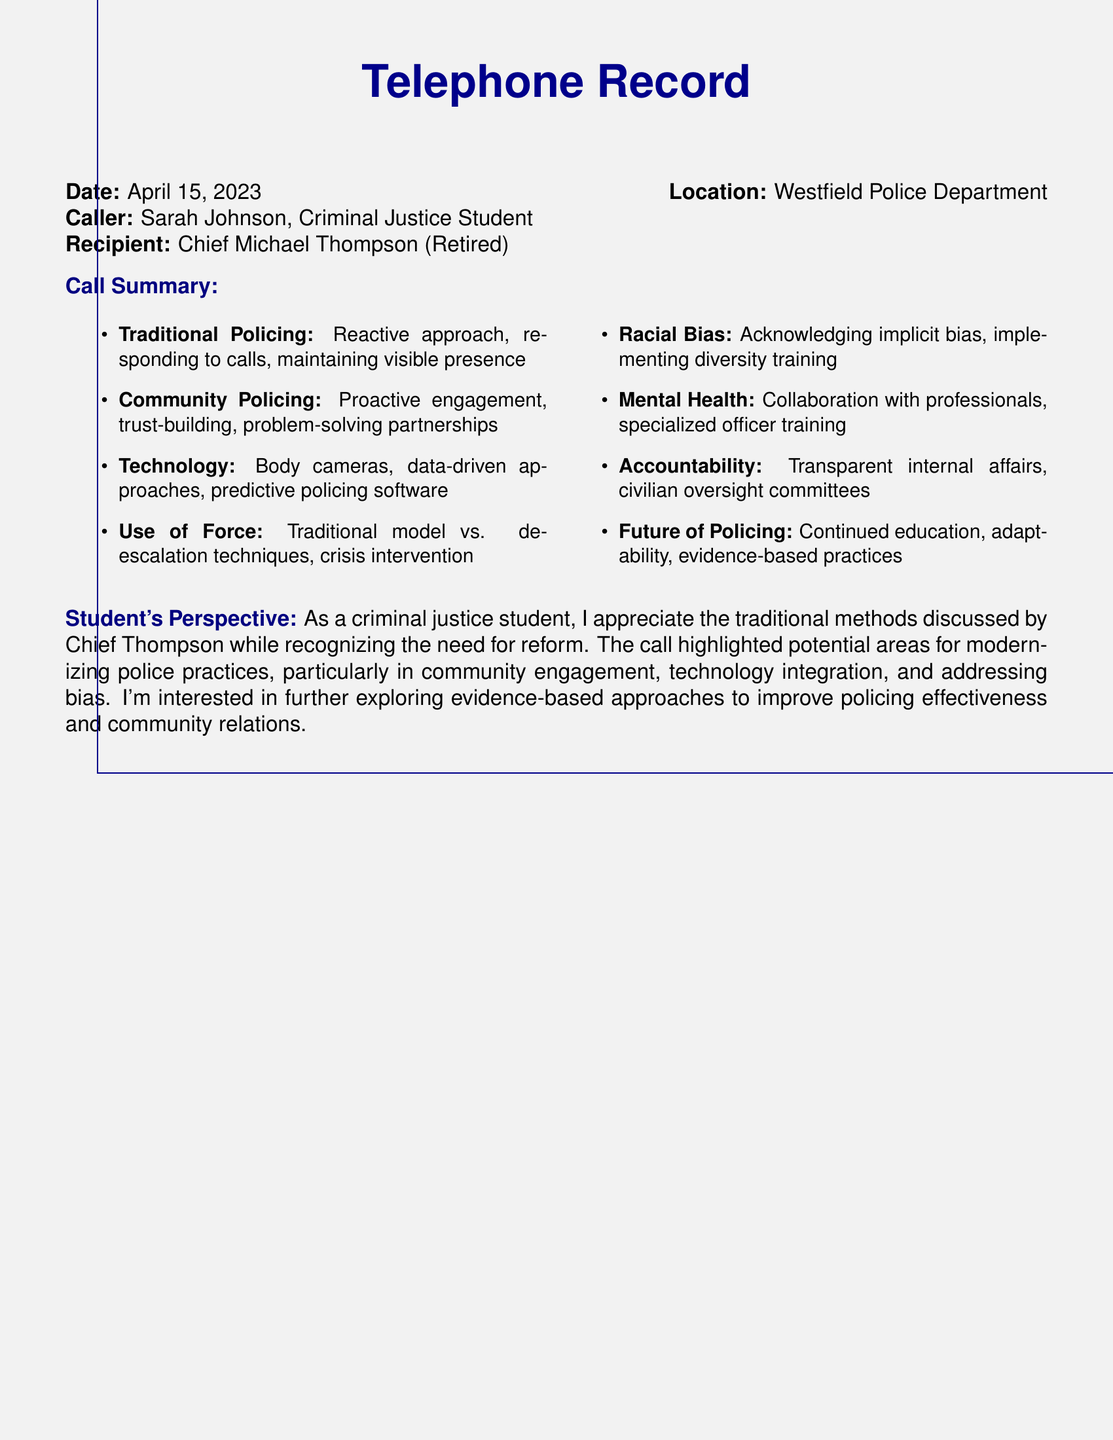What is the date of the call? The date of the call is stated in the document as April 15, 2023.
Answer: April 15, 2023 Who is the caller? The caller is identified as Sarah Johnson, a Criminal Justice Student.
Answer: Sarah Johnson What is Chief Thompson's title? The document specifies Chief Thompson's title as Retired Police Chief.
Answer: Retired What policing method emphasizes proactive engagement? The document mentions community policing as the method that emphasizes proactive engagement.
Answer: Community Policing What technology is mentioned for law enforcement improvement? The call summary highlights body cameras as a technology for law enforcement improvement.
Answer: Body cameras What key issue is acknowledged in policing? The call discusses the acknowledgment of implicit bias in policing practices.
Answer: Implicit bias What is one area for improvement in police practices? The document lists the need for collaboration with mental health professionals as an area for improvement.
Answer: Mental Health What is required for transparency in policing? The document states that transparent internal affairs are required for accountability in policing.
Answer: Internal affairs What is the future focus for policing according to the call? The future focus for policing includes continued education and adaptability, as stated in the document.
Answer: Continued education 